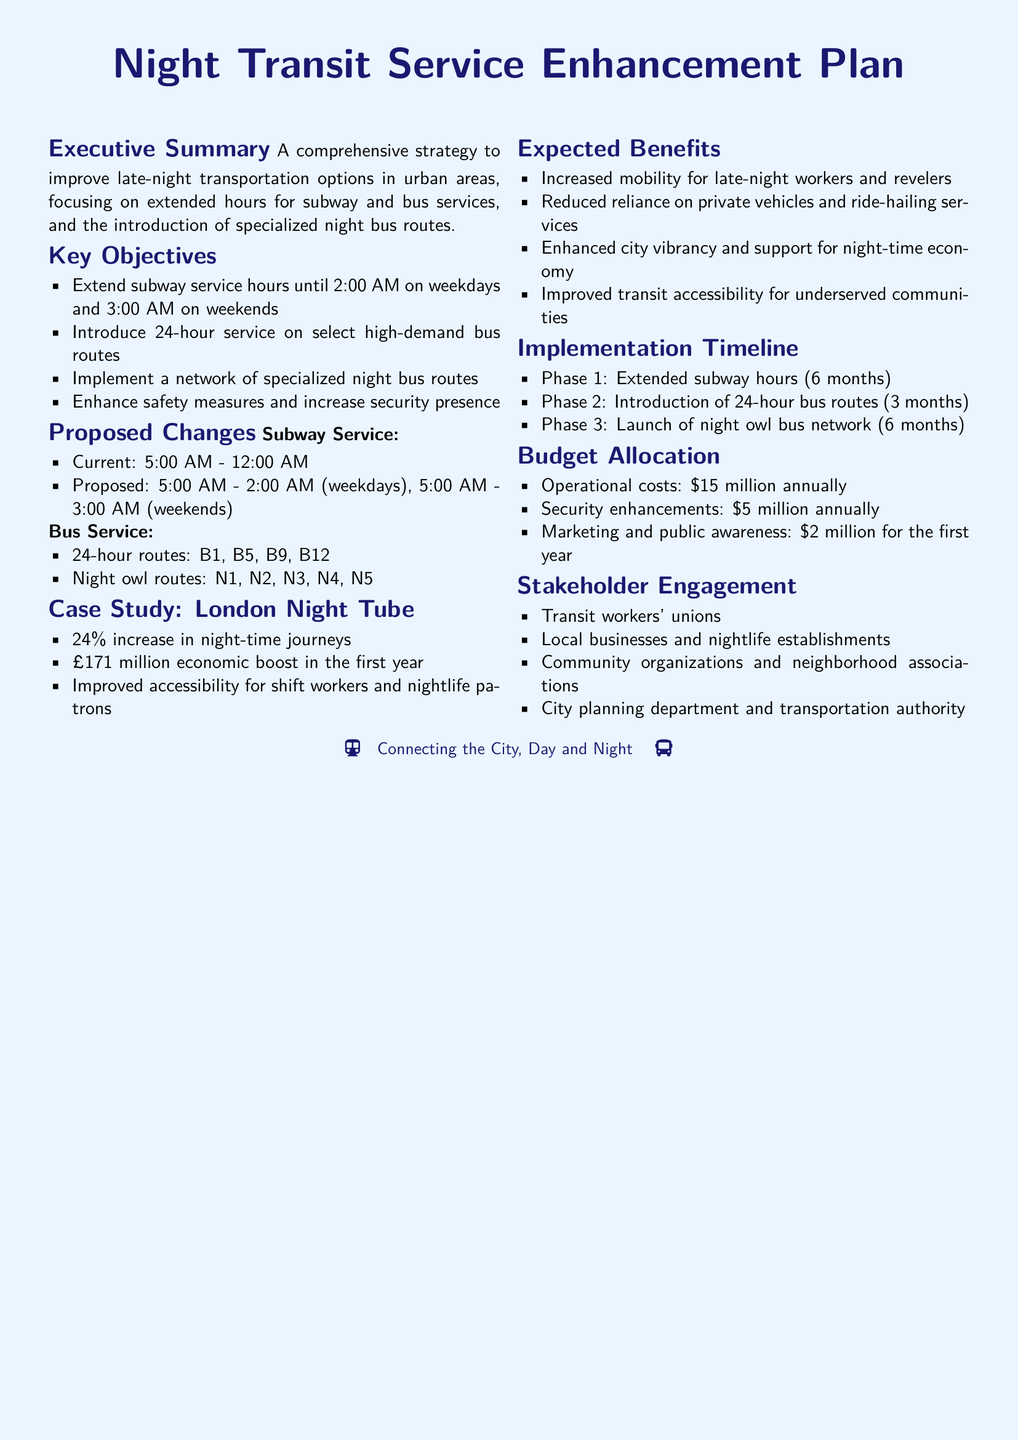what are the proposed subway service hours on weekends? The document states the proposed subway service hours will be 5:00 AM to 3:00 AM on weekends.
Answer: 5:00 AM - 3:00 AM how many phases are in the implementation timeline? The implementation timeline consists of three phases outlined in the document.
Answer: 3 what is the annual operational cost for the proposal? The document specifies the operational costs as fifteen million dollars annually.
Answer: $15 million which bus routes are categorized as night owl routes? The document lists N1, N2, N3, N4, and N5 as the night owl routes.
Answer: N1, N2, N3, N4, N5 what was the increase in night-time journeys after the London Night Tube was implemented? The document mentions a twenty-four percent increase in night-time journeys as a result of the London Night Tube.
Answer: 24% who are the stakeholders engaged in this plan? The document lists various stakeholders, including transit workers' unions and local businesses, as engaged parties.
Answer: Transit workers' unions, local businesses, community organizations, city planning department what is the budget allocated for marketing and public awareness in the first year? The document indicates that the budget for marketing and public awareness is two million dollars for the first year.
Answer: $2 million 